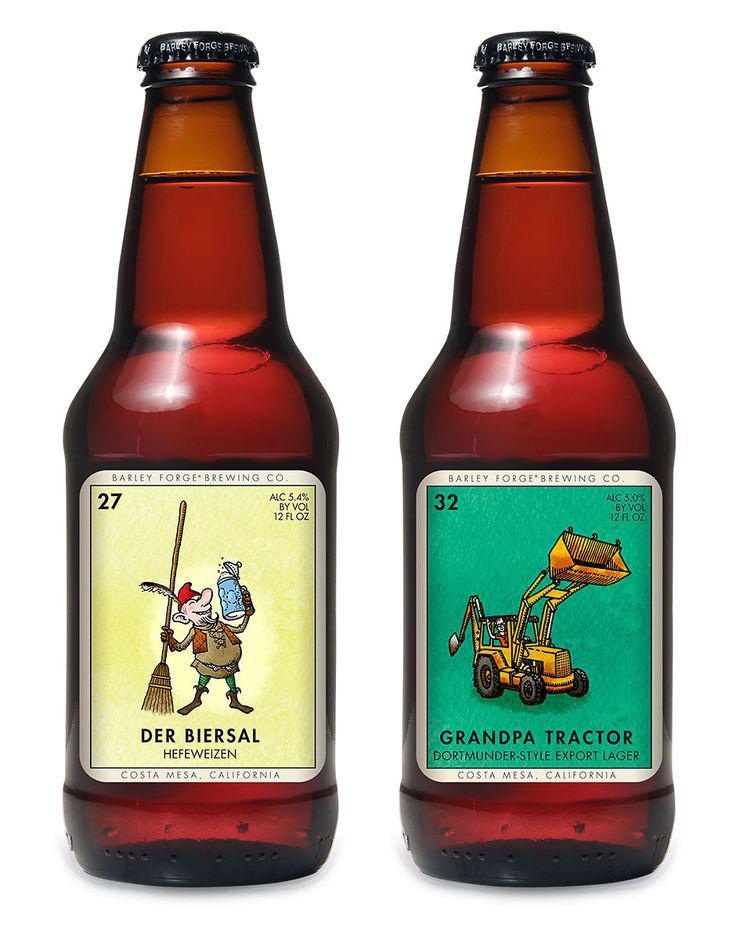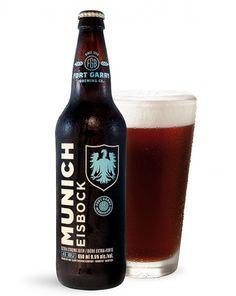The first image is the image on the left, the second image is the image on the right. For the images displayed, is the sentence "A total of five beer bottles are depicted." factually correct? Answer yes or no. No. 